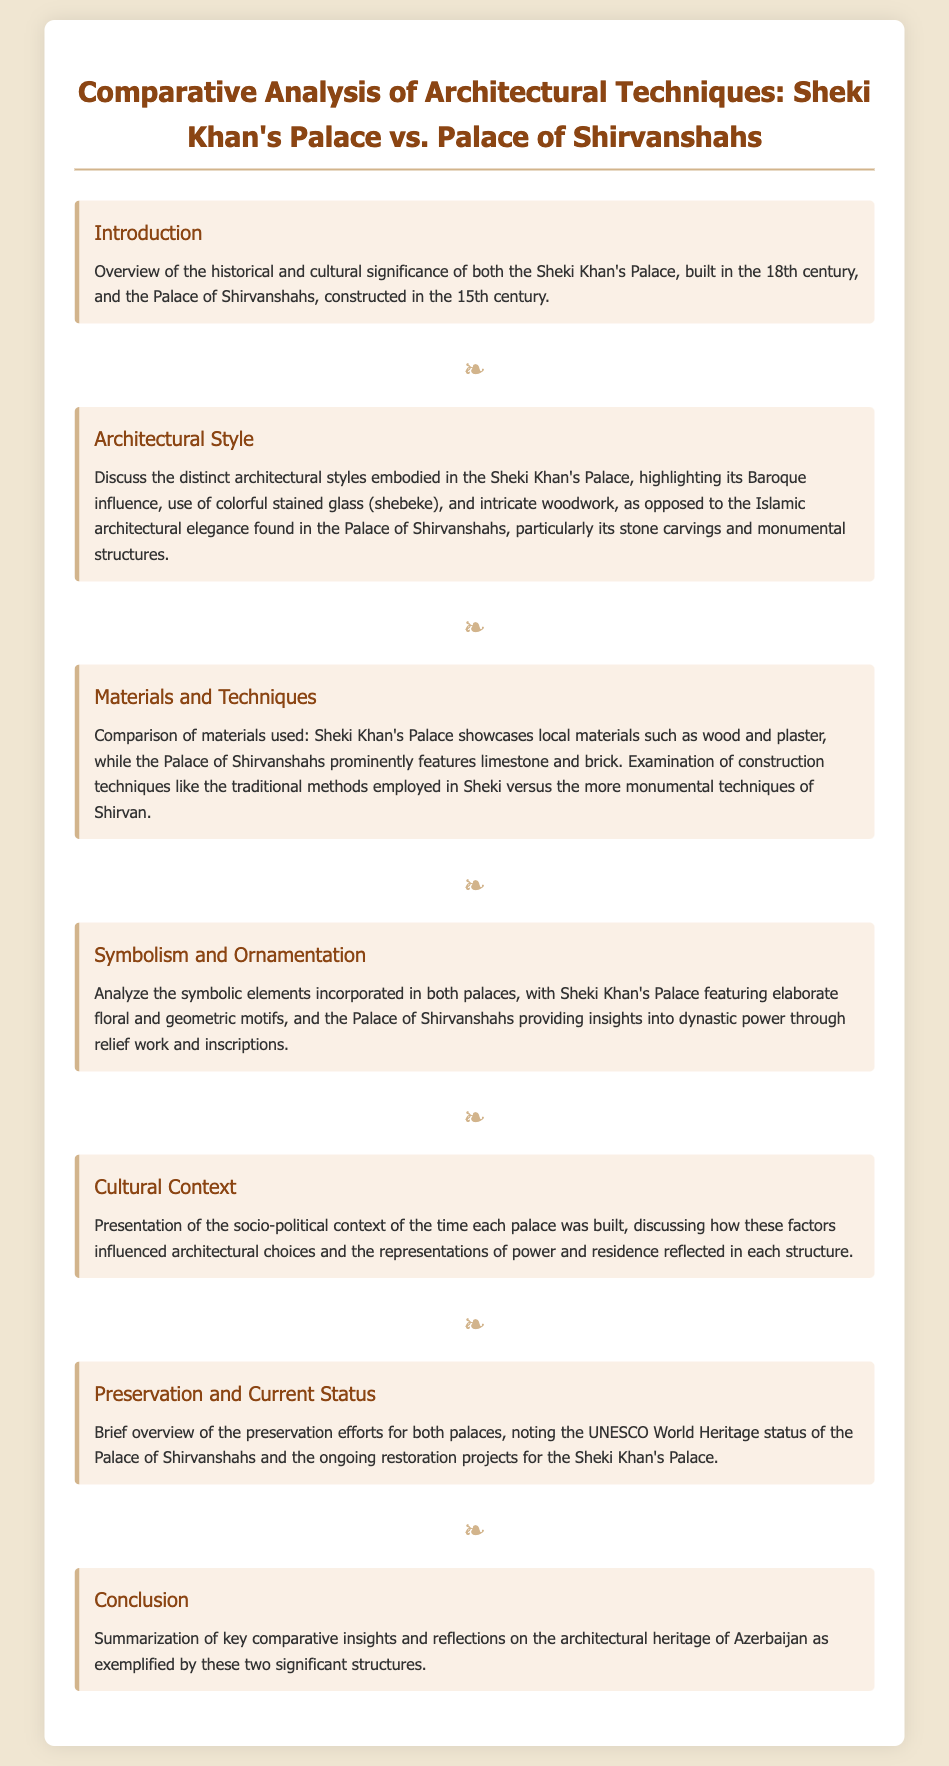What is the architectural style of Sheki Khan's Palace? The document states that the Sheki Khan's Palace embodies a Baroque influence.
Answer: Baroque What materials are prominently featured in the Palace of Shirvanshahs? The document mentions that the Palace of Shirvanshahs prominently features limestone and brick.
Answer: Limestone and brick In which century was Sheki Khan's Palace built? According to the introduction, Sheki Khan's Palace was built in the 18th century.
Answer: 18th century What is a key characteristic of the ornamentation in Sheki Khan's Palace? The document notes that Sheki Khan's Palace features elaborate floral and geometric motifs.
Answer: Floral and geometric motifs Which UNESCO status is mentioned for the Palace of Shirvanshahs? The document provides that the Palace of Shirvanshahs has UNESCO World Heritage status.
Answer: UNESCO World Heritage status What does the document suggest about the influence of socio-political context on architecture? It indicates that socio-political factors influenced architectural choices and the representations of power.
Answer: Architectural choices and representations of power What restoration project is mentioned in relation to Sheki Khan's Palace? The document notes ongoing restoration projects for Sheki Khan's Palace.
Answer: Ongoing restoration projects What is the main focus of the conclusion section? The conclusion section summarizes key comparative insights on architectural heritage of Azerbaijan.
Answer: Key comparative insights on architectural heritage 